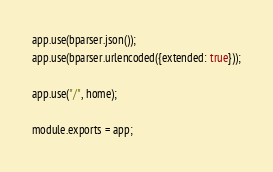Convert code to text. <code><loc_0><loc_0><loc_500><loc_500><_JavaScript_>
app.use(bparser.json());
app.use(bparser.urlencoded({extended: true}));

app.use("/", home);

module.exports = app;</code> 